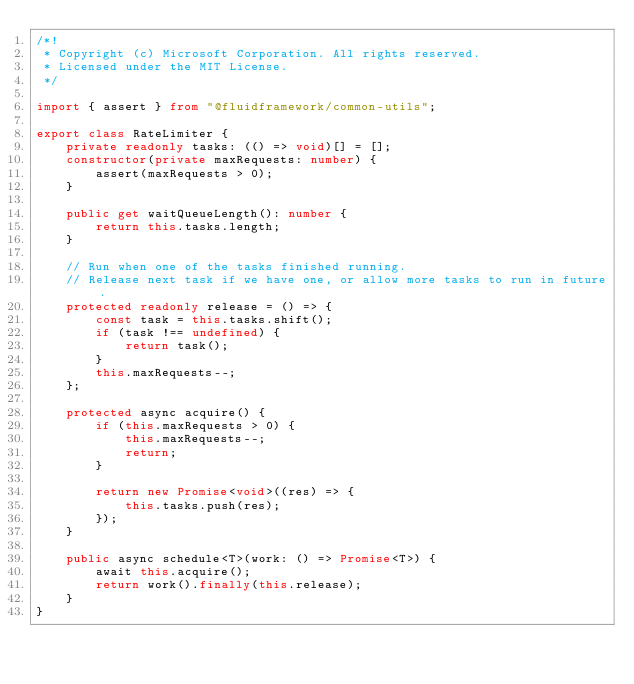Convert code to text. <code><loc_0><loc_0><loc_500><loc_500><_TypeScript_>/*!
 * Copyright (c) Microsoft Corporation. All rights reserved.
 * Licensed under the MIT License.
 */

import { assert } from "@fluidframework/common-utils";

export class RateLimiter {
    private readonly tasks: (() => void)[] = [];
    constructor(private maxRequests: number) {
        assert(maxRequests > 0);
    }

    public get waitQueueLength(): number {
        return this.tasks.length;
    }

    // Run when one of the tasks finished running.
    // Release next task if we have one, or allow more tasks to run in future.
    protected readonly release = () => {
        const task = this.tasks.shift();
        if (task !== undefined) {
            return task();
        }
        this.maxRequests--;
    };

    protected async acquire() {
        if (this.maxRequests > 0) {
            this.maxRequests--;
            return;
        }

        return new Promise<void>((res) => {
            this.tasks.push(res);
        });
    }

    public async schedule<T>(work: () => Promise<T>) {
        await this.acquire();
        return work().finally(this.release);
    }
}
</code> 